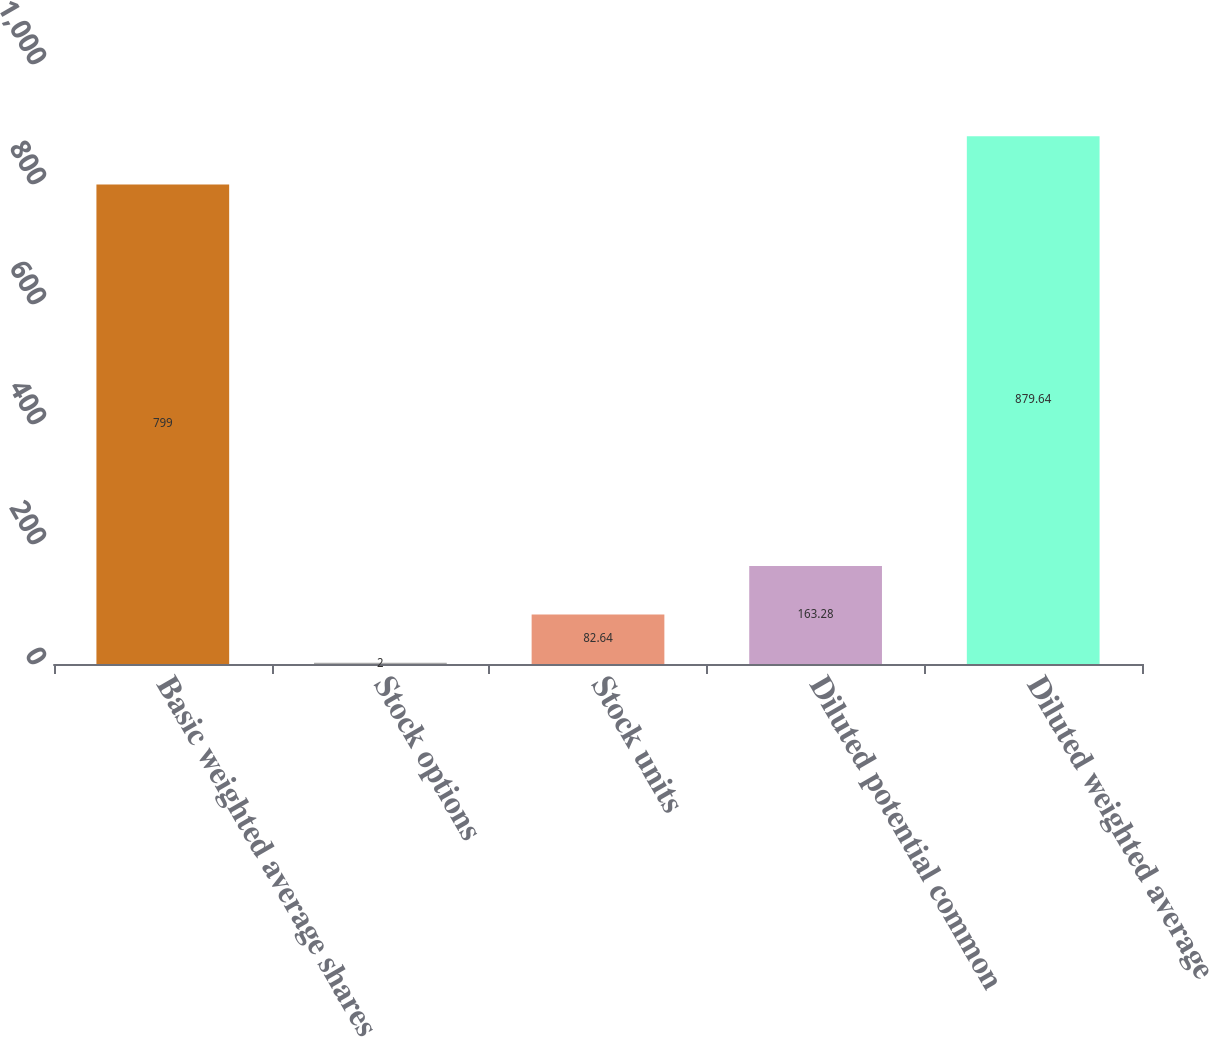<chart> <loc_0><loc_0><loc_500><loc_500><bar_chart><fcel>Basic weighted average shares<fcel>Stock options<fcel>Stock units<fcel>Diluted potential common<fcel>Diluted weighted average<nl><fcel>799<fcel>2<fcel>82.64<fcel>163.28<fcel>879.64<nl></chart> 